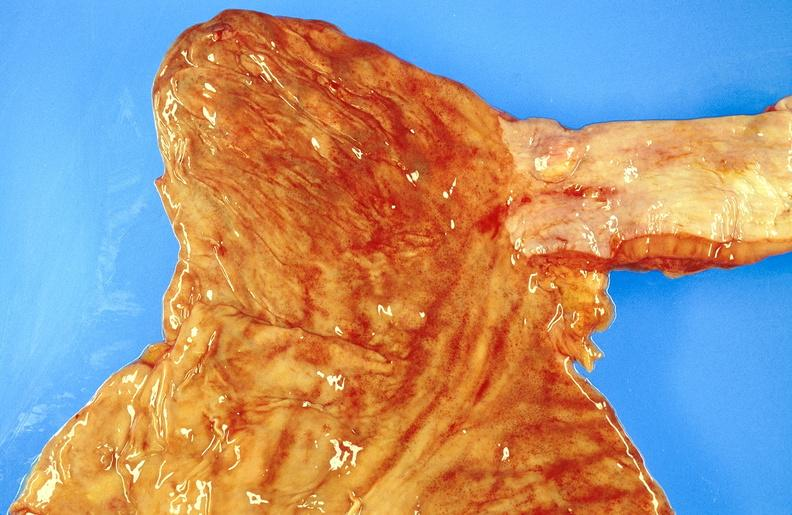s gastrointestinal present?
Answer the question using a single word or phrase. Yes 